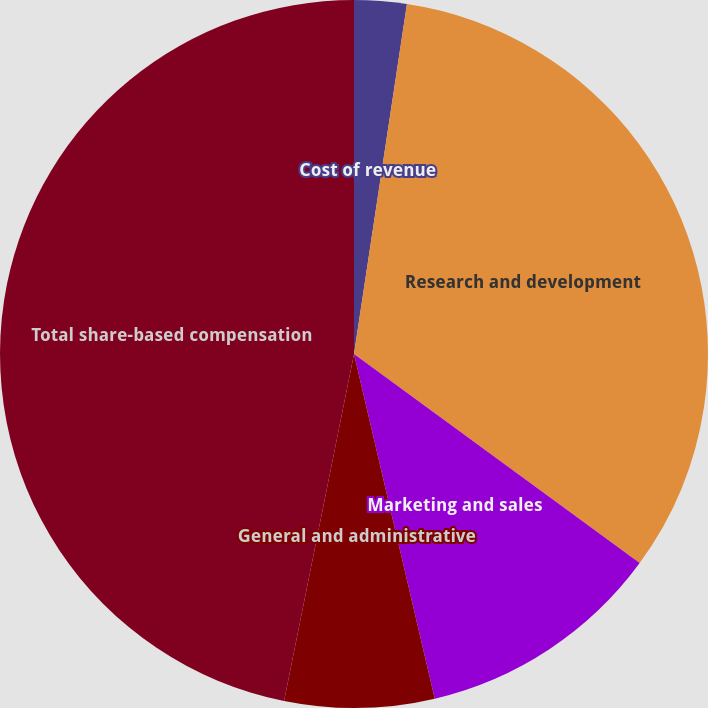Convert chart to OTSL. <chart><loc_0><loc_0><loc_500><loc_500><pie_chart><fcel>Cost of revenue<fcel>Research and development<fcel>Marketing and sales<fcel>General and administrative<fcel>Total share-based compensation<nl><fcel>2.39%<fcel>32.67%<fcel>11.28%<fcel>6.83%<fcel>46.84%<nl></chart> 